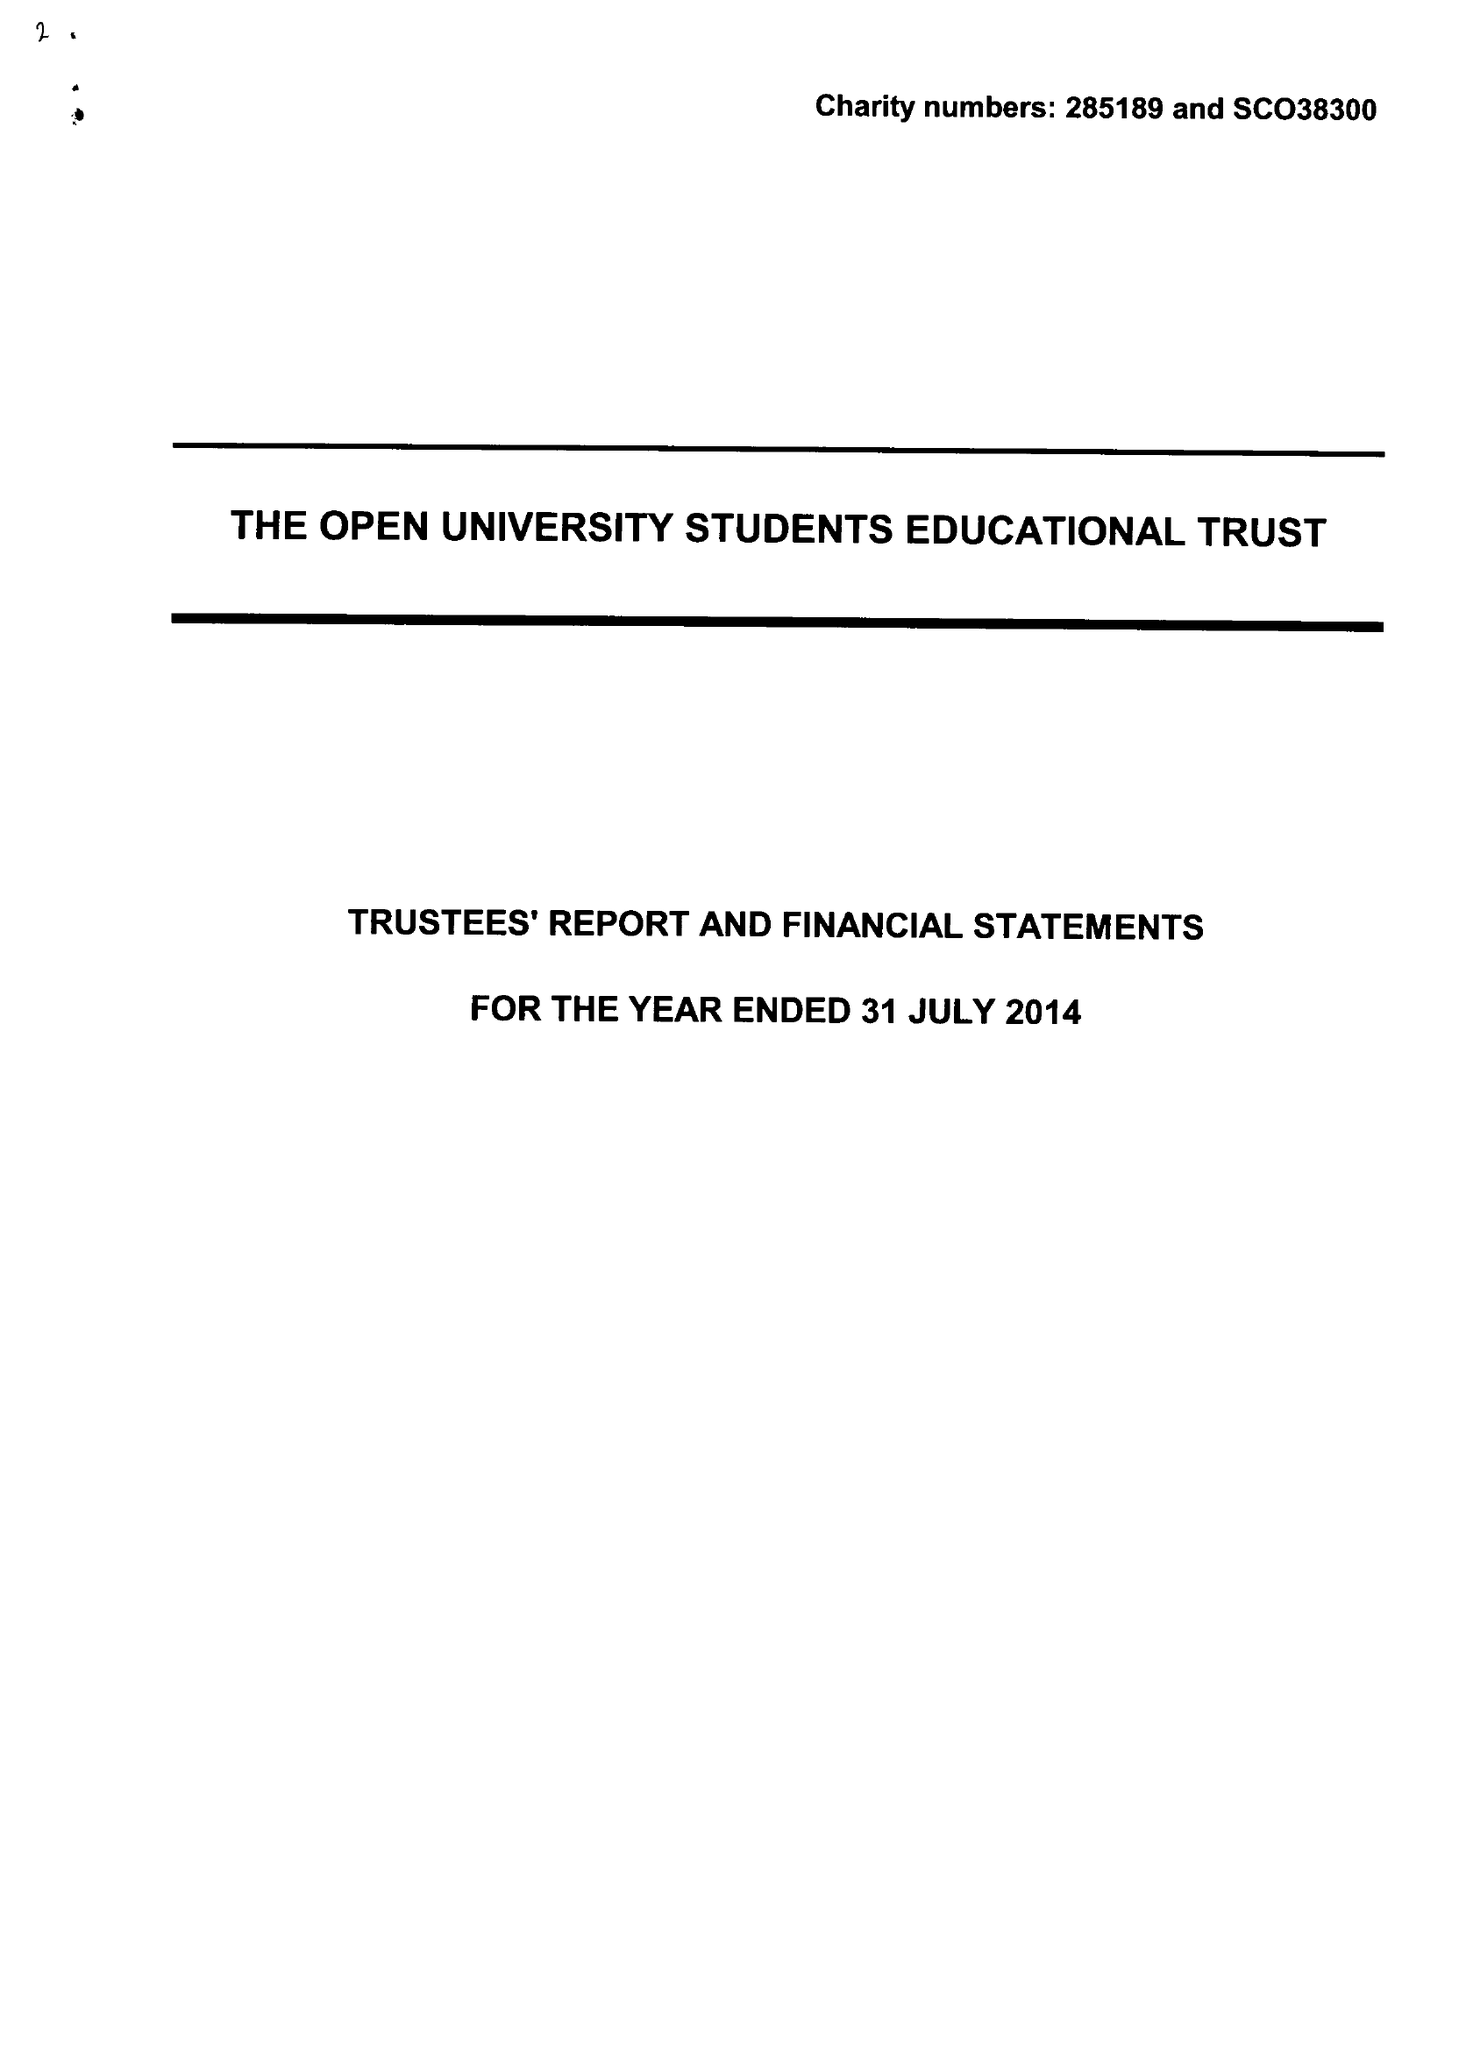What is the value for the income_annually_in_british_pounds?
Answer the question using a single word or phrase. 204517.00 